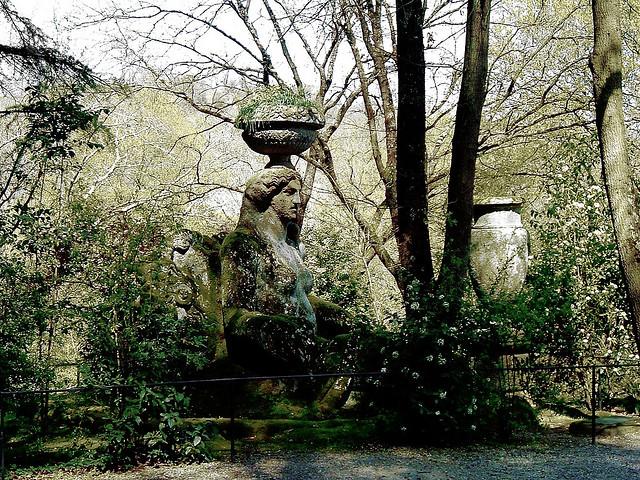How many statues are in this park?
Concise answer only. 2. What kind of statue is in this picture?
Answer briefly. Stone. What is the color of the flowers?
Keep it brief. White. 